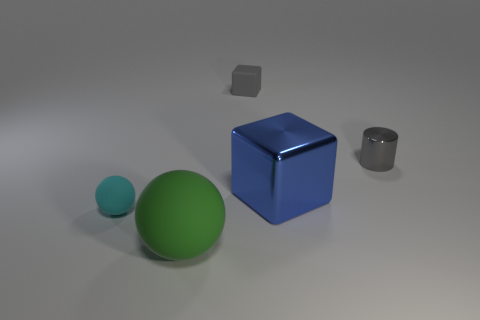Add 5 large rubber objects. How many objects exist? 10 Subtract all cubes. How many objects are left? 3 Add 5 gray matte things. How many gray matte things are left? 6 Add 4 purple matte cylinders. How many purple matte cylinders exist? 4 Subtract 0 yellow spheres. How many objects are left? 5 Subtract all tiny blocks. Subtract all large blue things. How many objects are left? 3 